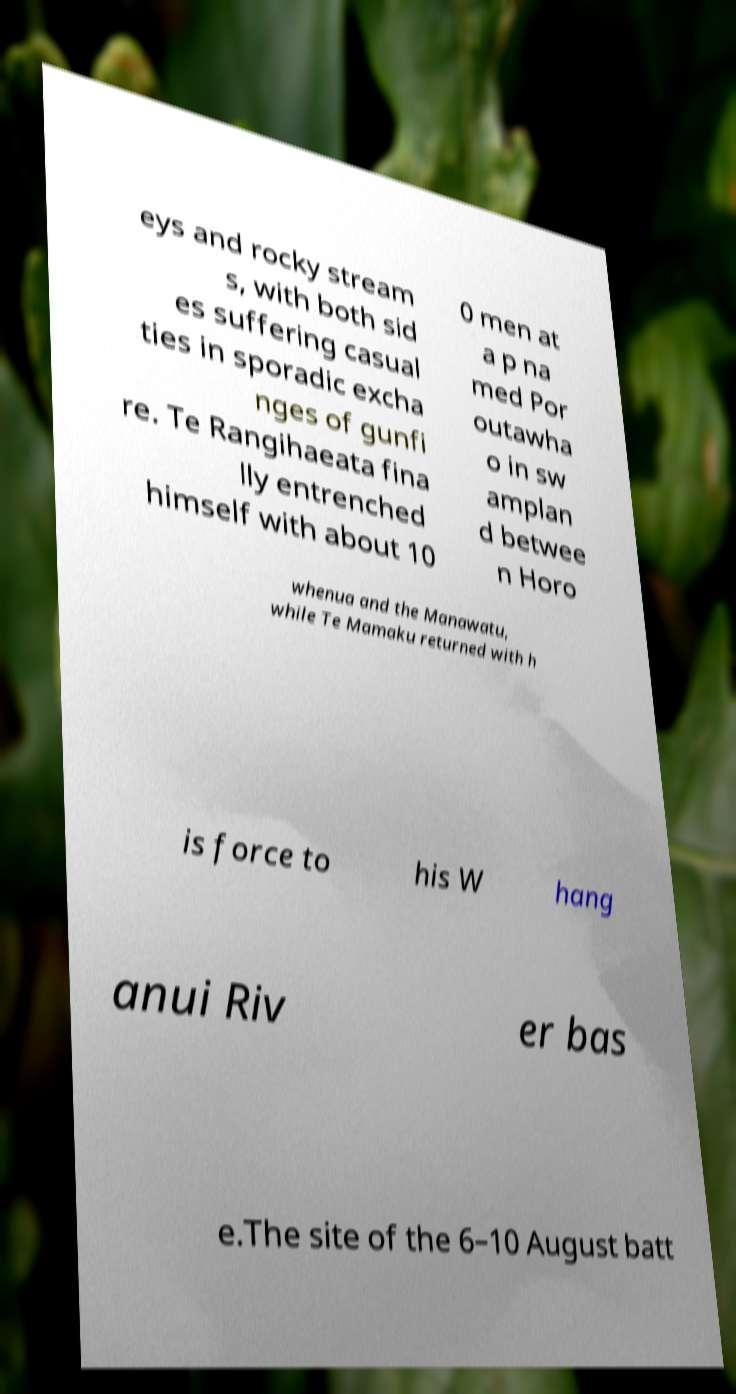There's text embedded in this image that I need extracted. Can you transcribe it verbatim? eys and rocky stream s, with both sid es suffering casual ties in sporadic excha nges of gunfi re. Te Rangihaeata fina lly entrenched himself with about 10 0 men at a p na med Por outawha o in sw amplan d betwee n Horo whenua and the Manawatu, while Te Mamaku returned with h is force to his W hang anui Riv er bas e.The site of the 6–10 August batt 